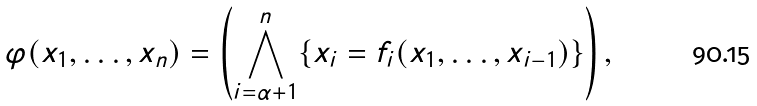<formula> <loc_0><loc_0><loc_500><loc_500>\varphi ( x _ { 1 } , \dots , x _ { n } ) = \left ( \bigwedge _ { i = \alpha + 1 } ^ { n } \{ x _ { i } = f _ { i } ( x _ { 1 } , \dots , x _ { i - 1 } ) \} \right ) ,</formula> 